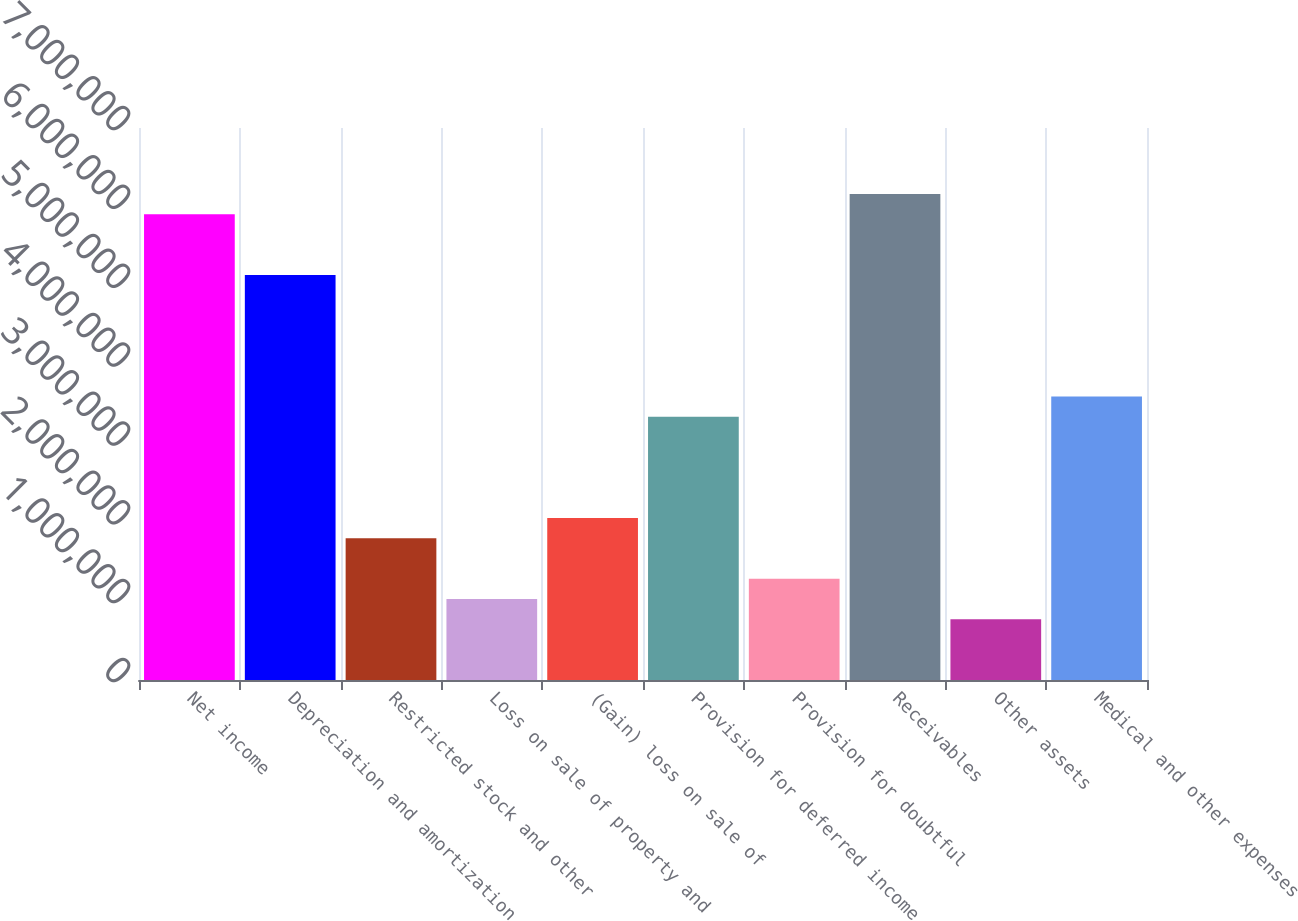Convert chart to OTSL. <chart><loc_0><loc_0><loc_500><loc_500><bar_chart><fcel>Net income<fcel>Depreciation and amortization<fcel>Restricted stock and other<fcel>Loss on sale of property and<fcel>(Gain) loss on sale of<fcel>Provision for deferred income<fcel>Provision for doubtful<fcel>Receivables<fcel>Other assets<fcel>Medical and other expenses<nl><fcel>5.90687e+06<fcel>5.13661e+06<fcel>1.79882e+06<fcel>1.02856e+06<fcel>2.05557e+06<fcel>3.33934e+06<fcel>1.28531e+06<fcel>6.16362e+06<fcel>771808<fcel>3.59609e+06<nl></chart> 